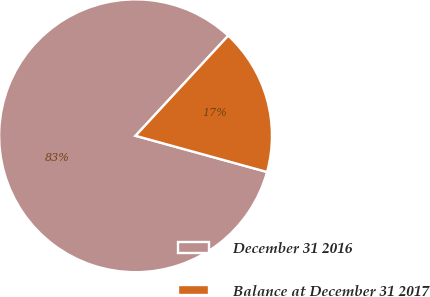Convert chart. <chart><loc_0><loc_0><loc_500><loc_500><pie_chart><fcel>December 31 2016<fcel>Balance at December 31 2017<nl><fcel>82.61%<fcel>17.39%<nl></chart> 